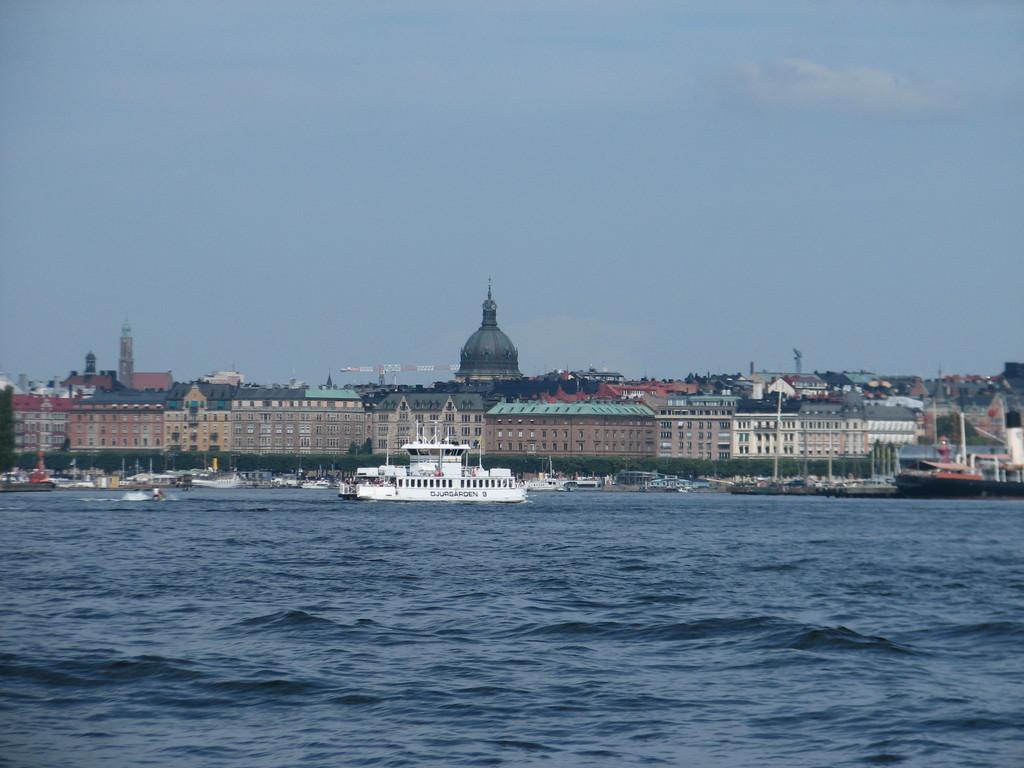Could you give a brief overview of what you see in this image? In this image I can see water. There are boats, trees, buildings and in the background there is sky. 